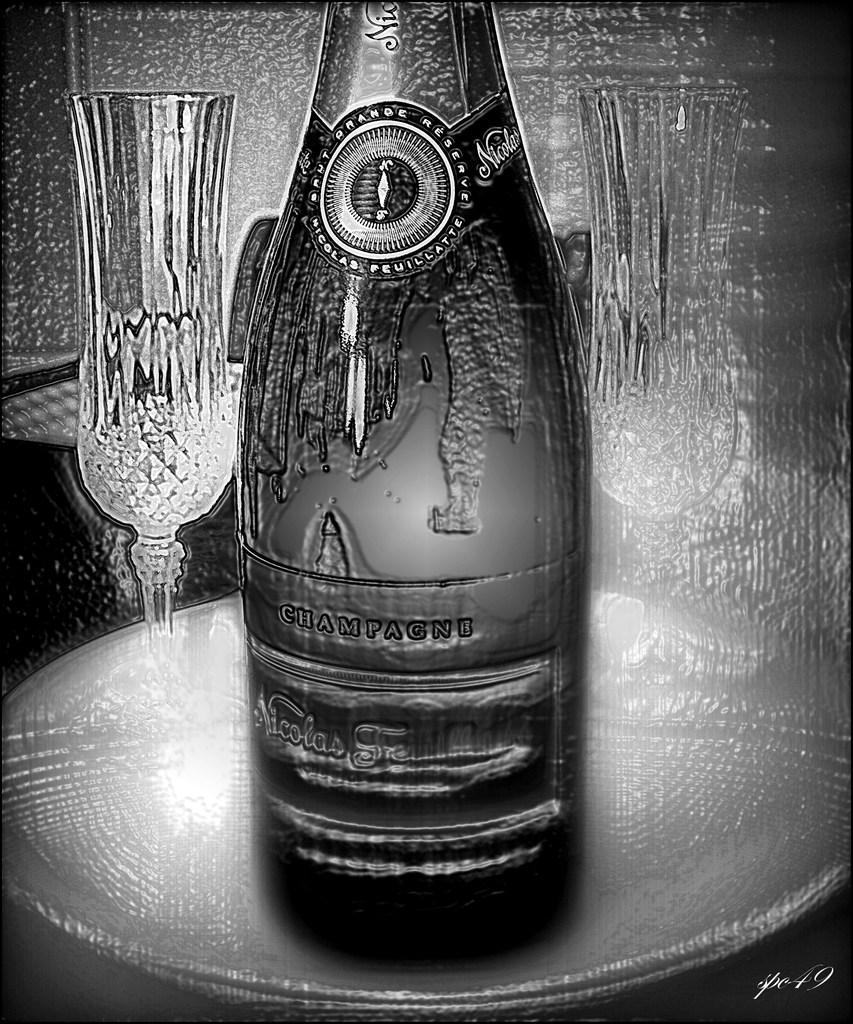How has the image been altered? The image is edited and black and white. What objects can be seen in the image? There is a bottle, glasses, and a plate in the image. Where is the plate located in the image? The plate is placed on a surface in the image. Can you see a farmer working in the fields in the image? No, there is no farmer or field present in the image. What type of nut is being cracked open on the plate in the image? There is no nut present on the plate in the image. 